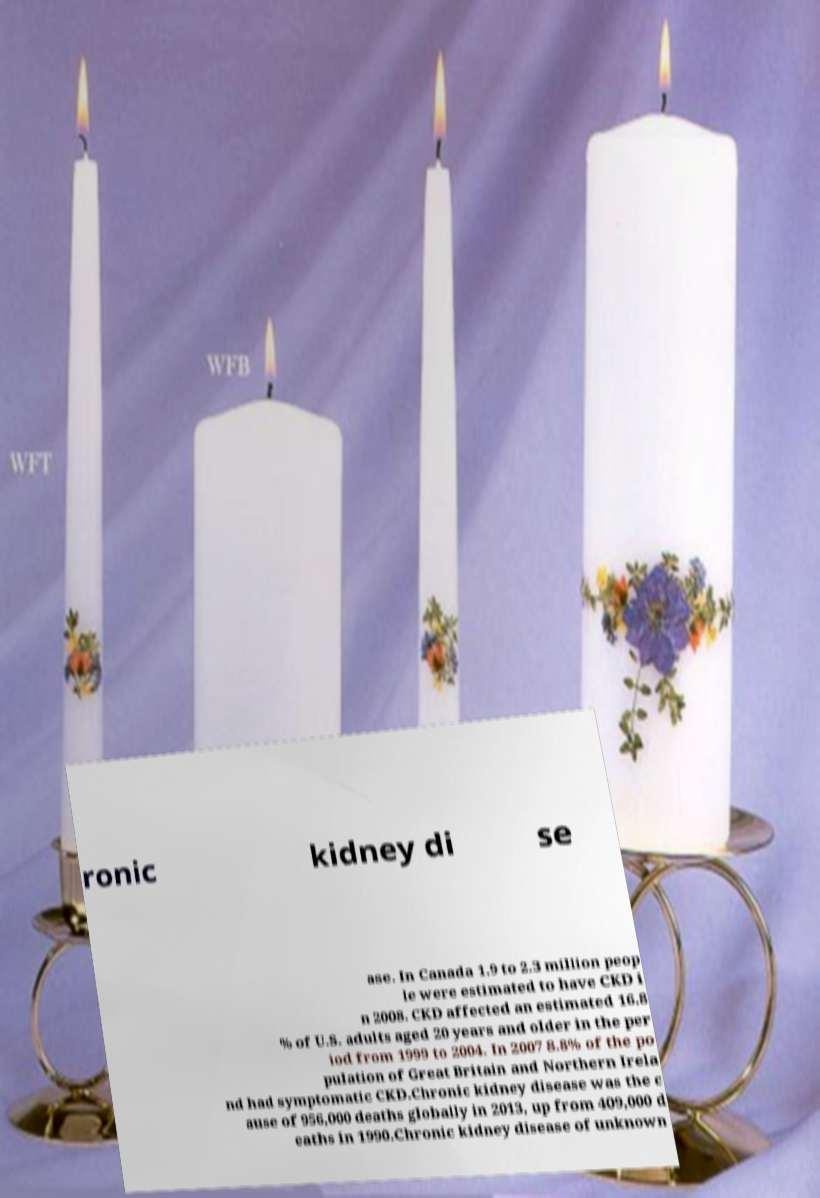For documentation purposes, I need the text within this image transcribed. Could you provide that? ronic kidney di se ase. In Canada 1.9 to 2.3 million peop le were estimated to have CKD i n 2008. CKD affected an estimated 16.8 % of U.S. adults aged 20 years and older in the per iod from 1999 to 2004. In 2007 8.8% of the po pulation of Great Britain and Northern Irela nd had symptomatic CKD.Chronic kidney disease was the c ause of 956,000 deaths globally in 2013, up from 409,000 d eaths in 1990.Chronic kidney disease of unknown 